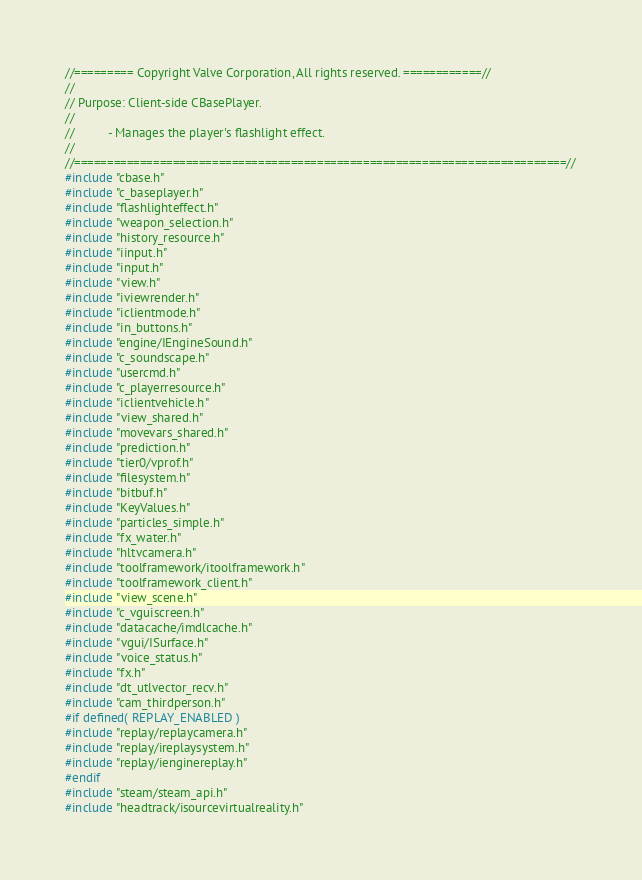<code> <loc_0><loc_0><loc_500><loc_500><_C++_>//========= Copyright Valve Corporation, All rights reserved. ============//
//
// Purpose: Client-side CBasePlayer.
//
//			- Manages the player's flashlight effect.
//
//===========================================================================//
#include "cbase.h"
#include "c_baseplayer.h"
#include "flashlighteffect.h"
#include "weapon_selection.h"
#include "history_resource.h"
#include "iinput.h"
#include "input.h"
#include "view.h"
#include "iviewrender.h"
#include "iclientmode.h"
#include "in_buttons.h"
#include "engine/IEngineSound.h"
#include "c_soundscape.h"
#include "usercmd.h"
#include "c_playerresource.h"
#include "iclientvehicle.h"
#include "view_shared.h"
#include "movevars_shared.h"
#include "prediction.h"
#include "tier0/vprof.h"
#include "filesystem.h"
#include "bitbuf.h"
#include "KeyValues.h"
#include "particles_simple.h"
#include "fx_water.h"
#include "hltvcamera.h"
#include "toolframework/itoolframework.h"
#include "toolframework_client.h"
#include "view_scene.h"
#include "c_vguiscreen.h"
#include "datacache/imdlcache.h"
#include "vgui/ISurface.h"
#include "voice_status.h"
#include "fx.h"
#include "dt_utlvector_recv.h"
#include "cam_thirdperson.h"
#if defined( REPLAY_ENABLED )
#include "replay/replaycamera.h"
#include "replay/ireplaysystem.h"
#include "replay/ienginereplay.h"
#endif
#include "steam/steam_api.h"
#include "headtrack/isourcevirtualreality.h"</code> 